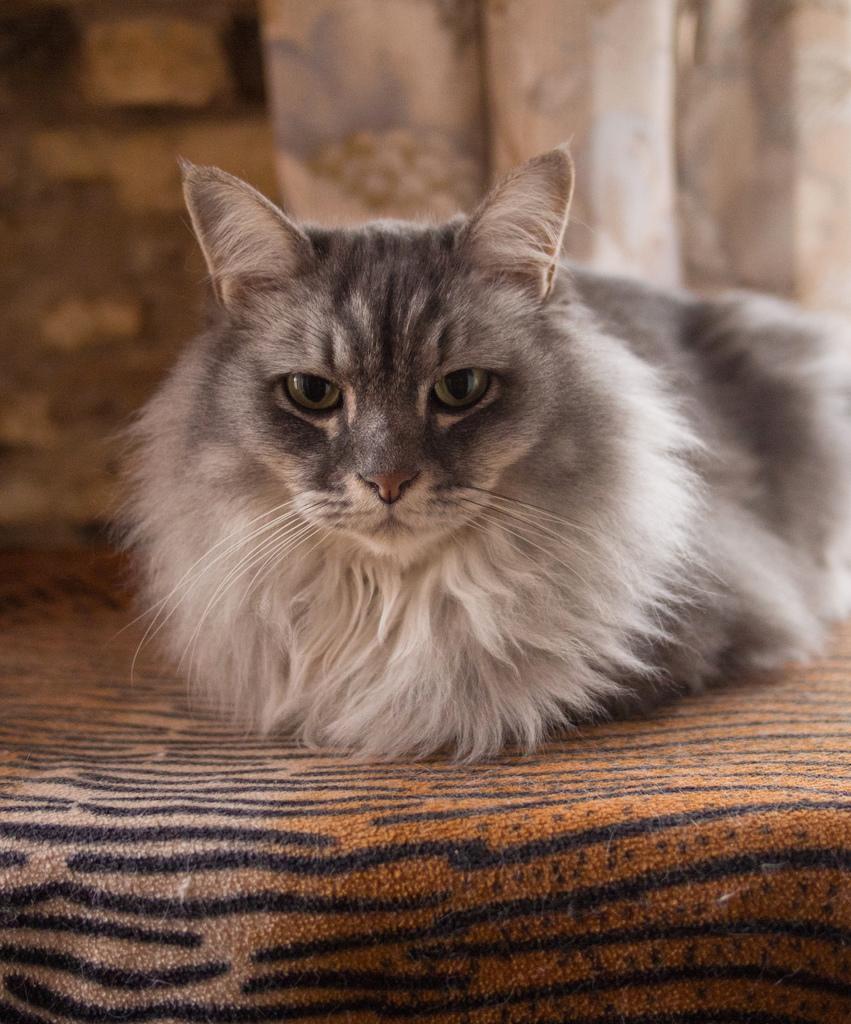Describe this image in one or two sentences. A cat is sitting. There are curtains at the back. 